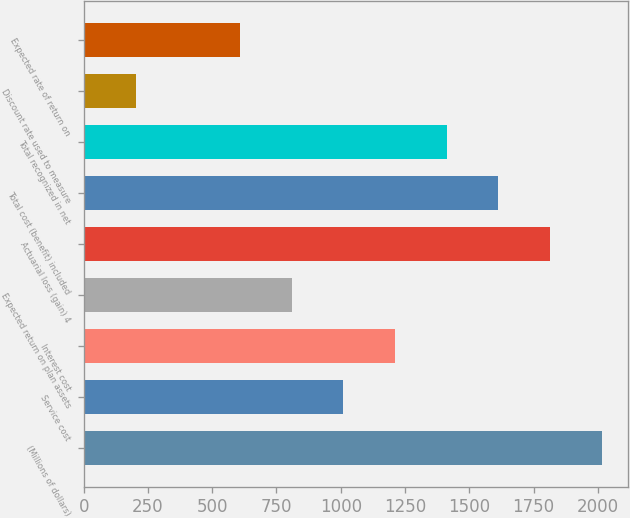Convert chart. <chart><loc_0><loc_0><loc_500><loc_500><bar_chart><fcel>(Millions of dollars)<fcel>Service cost<fcel>Interest cost<fcel>Expected return on plan assets<fcel>Actuarial loss (gain) 4<fcel>Total cost (benefit) included<fcel>Total recognized in net<fcel>Discount rate used to measure<fcel>Expected rate of return on<nl><fcel>2015<fcel>1009.45<fcel>1210.56<fcel>808.34<fcel>1813.89<fcel>1612.78<fcel>1411.67<fcel>205.01<fcel>607.23<nl></chart> 